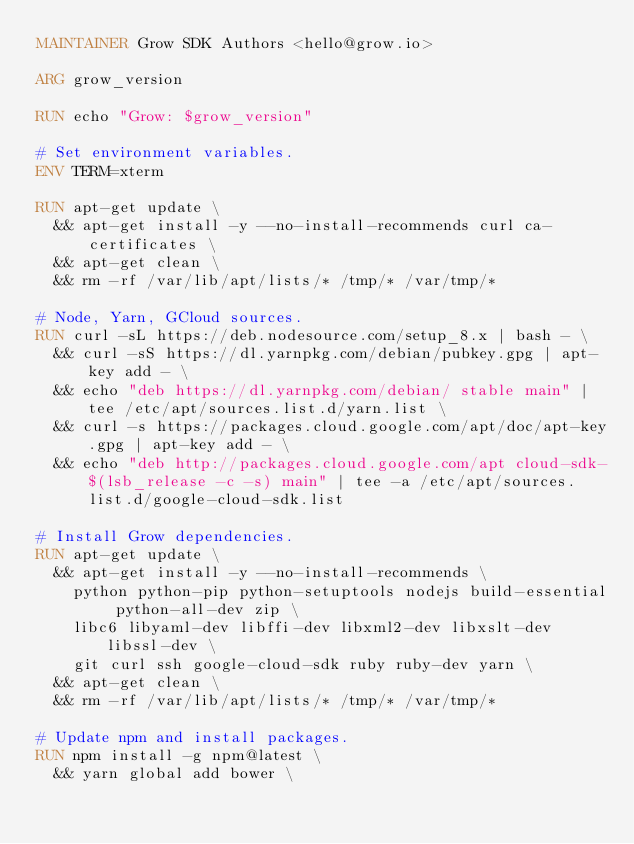<code> <loc_0><loc_0><loc_500><loc_500><_Dockerfile_>MAINTAINER Grow SDK Authors <hello@grow.io>

ARG grow_version

RUN echo "Grow: $grow_version"

# Set environment variables.
ENV TERM=xterm

RUN apt-get update \
  && apt-get install -y --no-install-recommends curl ca-certificates \
  && apt-get clean \
  && rm -rf /var/lib/apt/lists/* /tmp/* /var/tmp/*

# Node, Yarn, GCloud sources.
RUN curl -sL https://deb.nodesource.com/setup_8.x | bash - \
  && curl -sS https://dl.yarnpkg.com/debian/pubkey.gpg | apt-key add - \
  && echo "deb https://dl.yarnpkg.com/debian/ stable main" | tee /etc/apt/sources.list.d/yarn.list \
  && curl -s https://packages.cloud.google.com/apt/doc/apt-key.gpg | apt-key add - \
  && echo "deb http://packages.cloud.google.com/apt cloud-sdk-$(lsb_release -c -s) main" | tee -a /etc/apt/sources.list.d/google-cloud-sdk.list

# Install Grow dependencies.
RUN apt-get update \
  && apt-get install -y --no-install-recommends \
    python python-pip python-setuptools nodejs build-essential python-all-dev zip \
    libc6 libyaml-dev libffi-dev libxml2-dev libxslt-dev libssl-dev \
    git curl ssh google-cloud-sdk ruby ruby-dev yarn \
  && apt-get clean \
  && rm -rf /var/lib/apt/lists/* /tmp/* /var/tmp/*

# Update npm and install packages.
RUN npm install -g npm@latest \
  && yarn global add bower \</code> 